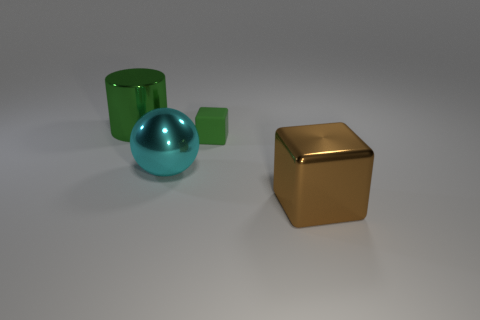Add 1 big blue metallic cubes. How many objects exist? 5 Subtract all cylinders. How many objects are left? 3 Subtract all green blocks. How many blocks are left? 1 Subtract 1 cyan balls. How many objects are left? 3 Subtract 1 blocks. How many blocks are left? 1 Subtract all blue blocks. Subtract all gray cylinders. How many blocks are left? 2 Subtract all big metal cylinders. Subtract all shiny cylinders. How many objects are left? 2 Add 1 tiny green rubber objects. How many tiny green rubber objects are left? 2 Add 1 green rubber objects. How many green rubber objects exist? 2 